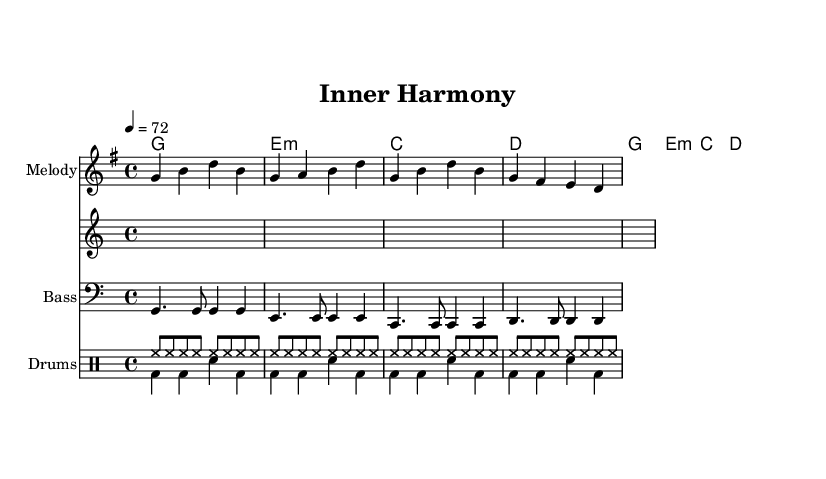What is the key signature of this music? The key signature is G major, which has one sharp (F#). You can find this by looking at the key signature indicated in the left margin of the sheet music.
Answer: G major What is the time signature of this music? The time signature is 4/4, indicated at the beginning of the sheet music. This means there are four beats in a measure and the quarter note gets one beat.
Answer: 4/4 What is the tempo marking for this piece? The tempo marking is a quarter note equals seventy-two beats per minute. This is commonly indicated alongside the time signature at the start of the music.
Answer: 72 How many measures are in the melody section? The melody section contains four measures. You can count the measures in the melody part, each separated by a vertical line.
Answer: Four What is the style of this piece of music? The style is reggae, which typically features a laid-back rhythm and offbeat accents. This piece embodies those characteristics through its rhythmic patterns and instrumentation.
Answer: Reggae Identify one element that is characteristic of reggae in this piece. One characteristic of reggae in this piece is the use of a steady, upbeat drum pattern combined with syncopated rhythms. In the drum section, you can observe the hi-hat (hh) and bass drum (bd) patterns that create this laid-back feel.
Answer: Steady drum pattern What do the lyrics in the verse emphasize? The lyrics in the verse emphasize mindfulness and letting go of worries, which aligns with the calming nature of yoga and meditation practices. "Breathe in the moment" indicates a focus on self-awareness and presence.
Answer: Mindfulness 